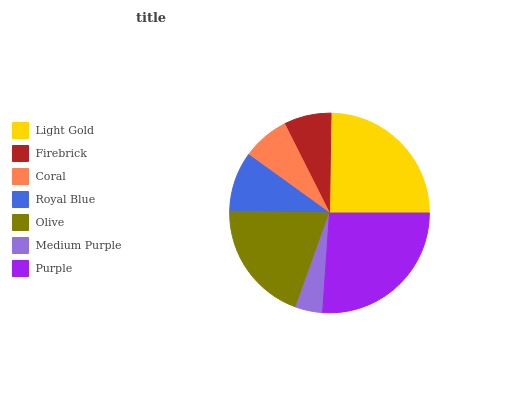Is Medium Purple the minimum?
Answer yes or no. Yes. Is Purple the maximum?
Answer yes or no. Yes. Is Firebrick the minimum?
Answer yes or no. No. Is Firebrick the maximum?
Answer yes or no. No. Is Light Gold greater than Firebrick?
Answer yes or no. Yes. Is Firebrick less than Light Gold?
Answer yes or no. Yes. Is Firebrick greater than Light Gold?
Answer yes or no. No. Is Light Gold less than Firebrick?
Answer yes or no. No. Is Royal Blue the high median?
Answer yes or no. Yes. Is Royal Blue the low median?
Answer yes or no. Yes. Is Coral the high median?
Answer yes or no. No. Is Firebrick the low median?
Answer yes or no. No. 